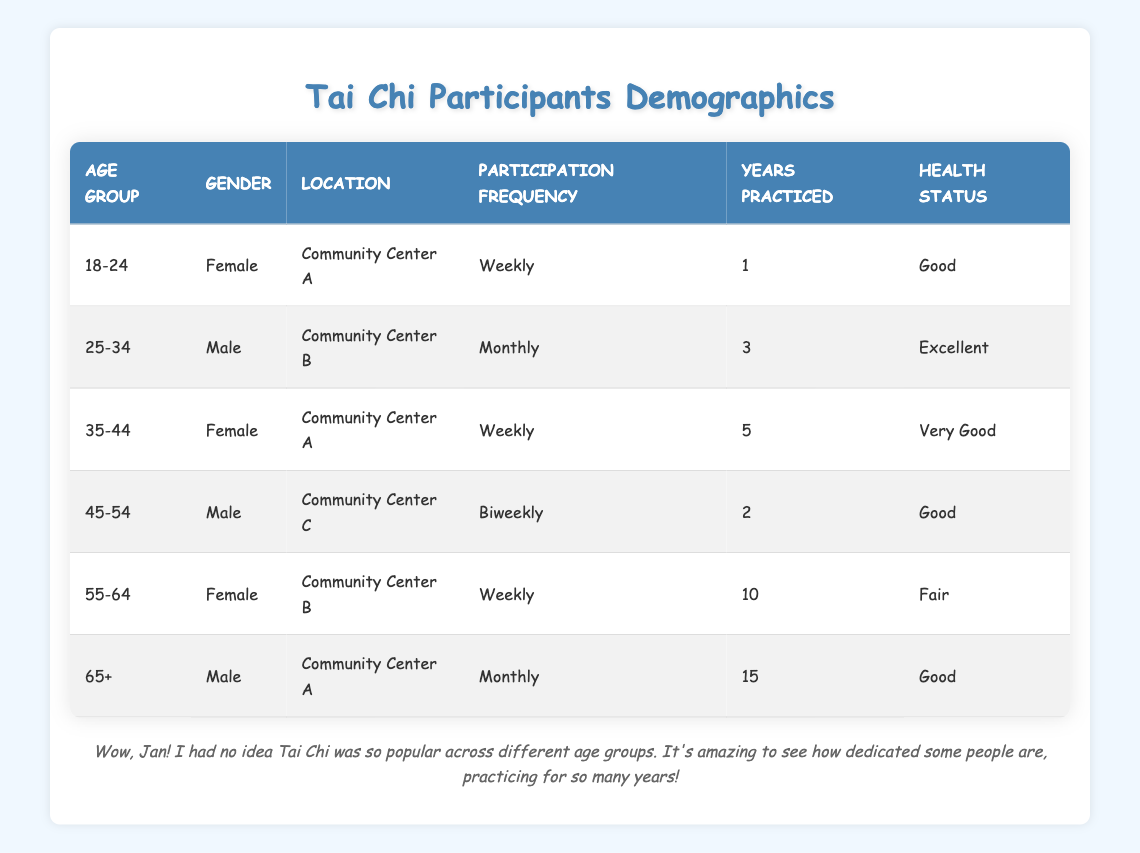What is the health status of participants aged 18-24? The health status for the participant in the age group 18-24 is noted in the table as 'Good'.
Answer: Good How many years has the oldest participant (aged 65+) practiced Tai Chi? The oldest participant, who is in the age group 65+, has practiced Tai Chi for 15 years, as indicated in the table.
Answer: 15 How many participants are there from Community Center A? The table shows that there are three participants from Community Center A: one aged 18-24 (Female), one aged 35-44 (Female), and one aged 65+ (Male).
Answer: 3 What is the average number of years practiced by male participants? The males in the table have practiced for the following years: 3 years (age 25-34), 2 years (age 45-54), and 15 years (age 65+). To calculate the average: (3 + 2 + 15) / 3 = 20 / 3 = 6.67 years.
Answer: 6.67 Is there a participant aged 55-64 with a health status of 'Excellent'? The table shows that the participant aged 55-64 has a health status of 'Fair', while no other participant in this age group is listed, so the answer is no.
Answer: No What is the most common participation frequency among the participants? The participation frequencies listed are Weekly (three participants), Monthly (two participants), and Biweekly (one participant). Since 'Weekly' has the highest count, it is the most common frequency.
Answer: Weekly How many participants reported a 'Very Good' health status? According to the table, only one participant (aged 35-44, Female) reported a 'Very Good' health status.
Answer: 1 What percentage of the total participants are female? There are three female participants out of a total of six, so the percentage is (3 / 6) * 100 = 50%.
Answer: 50% 